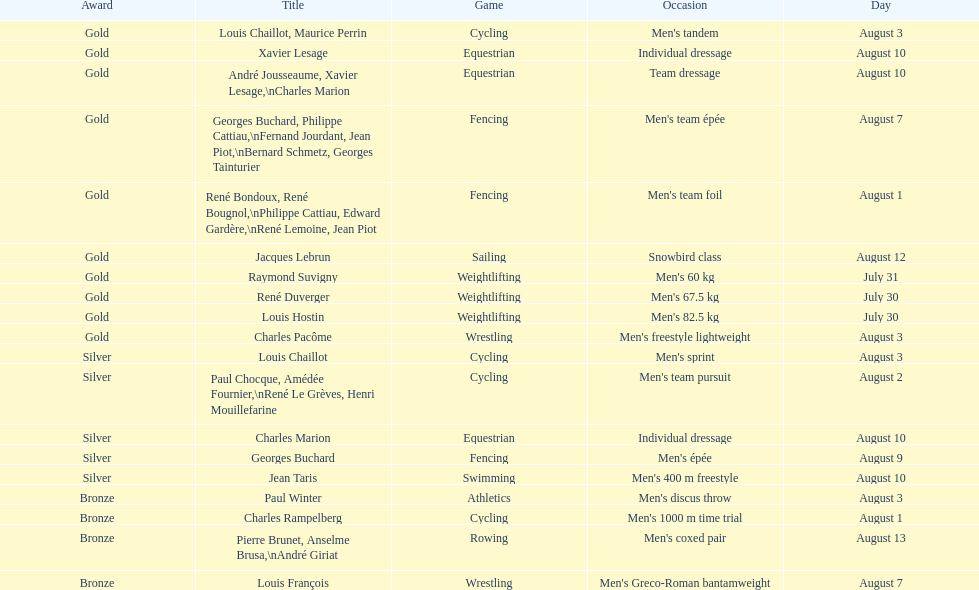How many medals were won after august 3? 9. 